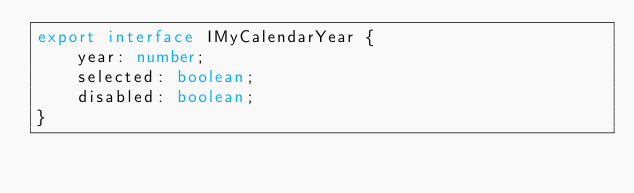<code> <loc_0><loc_0><loc_500><loc_500><_TypeScript_>export interface IMyCalendarYear {
    year: number;
    selected: boolean;
    disabled: boolean;
}
</code> 